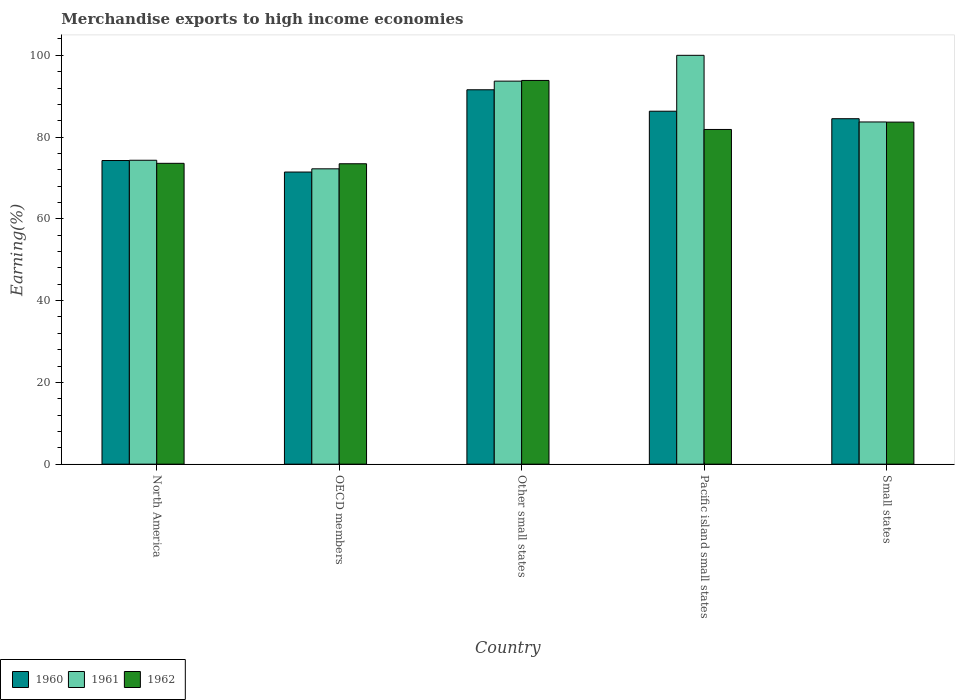How many different coloured bars are there?
Offer a very short reply. 3. Are the number of bars per tick equal to the number of legend labels?
Keep it short and to the point. Yes. How many bars are there on the 2nd tick from the left?
Offer a very short reply. 3. What is the label of the 3rd group of bars from the left?
Your answer should be compact. Other small states. What is the percentage of amount earned from merchandise exports in 1961 in North America?
Your answer should be very brief. 74.33. Across all countries, what is the minimum percentage of amount earned from merchandise exports in 1962?
Give a very brief answer. 73.48. In which country was the percentage of amount earned from merchandise exports in 1960 maximum?
Provide a short and direct response. Other small states. In which country was the percentage of amount earned from merchandise exports in 1960 minimum?
Offer a terse response. OECD members. What is the total percentage of amount earned from merchandise exports in 1962 in the graph?
Make the answer very short. 406.45. What is the difference between the percentage of amount earned from merchandise exports in 1962 in OECD members and that in Small states?
Your response must be concise. -10.19. What is the difference between the percentage of amount earned from merchandise exports in 1961 in OECD members and the percentage of amount earned from merchandise exports in 1960 in Small states?
Offer a terse response. -12.25. What is the average percentage of amount earned from merchandise exports in 1961 per country?
Give a very brief answer. 84.79. What is the difference between the percentage of amount earned from merchandise exports of/in 1961 and percentage of amount earned from merchandise exports of/in 1960 in Pacific island small states?
Your response must be concise. 13.67. In how many countries, is the percentage of amount earned from merchandise exports in 1962 greater than 92 %?
Provide a short and direct response. 1. What is the ratio of the percentage of amount earned from merchandise exports in 1962 in North America to that in Pacific island small states?
Provide a short and direct response. 0.9. Is the percentage of amount earned from merchandise exports in 1961 in North America less than that in Small states?
Offer a terse response. Yes. Is the difference between the percentage of amount earned from merchandise exports in 1961 in Other small states and Small states greater than the difference between the percentage of amount earned from merchandise exports in 1960 in Other small states and Small states?
Offer a very short reply. Yes. What is the difference between the highest and the second highest percentage of amount earned from merchandise exports in 1961?
Give a very brief answer. -16.3. What is the difference between the highest and the lowest percentage of amount earned from merchandise exports in 1960?
Give a very brief answer. 20.12. In how many countries, is the percentage of amount earned from merchandise exports in 1960 greater than the average percentage of amount earned from merchandise exports in 1960 taken over all countries?
Offer a very short reply. 3. What does the 2nd bar from the right in Pacific island small states represents?
Your answer should be very brief. 1961. Is it the case that in every country, the sum of the percentage of amount earned from merchandise exports in 1962 and percentage of amount earned from merchandise exports in 1961 is greater than the percentage of amount earned from merchandise exports in 1960?
Give a very brief answer. Yes. Are all the bars in the graph horizontal?
Keep it short and to the point. No. How many countries are there in the graph?
Ensure brevity in your answer.  5. Does the graph contain any zero values?
Keep it short and to the point. No. Does the graph contain grids?
Offer a very short reply. No. How are the legend labels stacked?
Offer a terse response. Horizontal. What is the title of the graph?
Make the answer very short. Merchandise exports to high income economies. What is the label or title of the X-axis?
Keep it short and to the point. Country. What is the label or title of the Y-axis?
Make the answer very short. Earning(%). What is the Earning(%) in 1960 in North America?
Provide a short and direct response. 74.27. What is the Earning(%) in 1961 in North America?
Provide a short and direct response. 74.33. What is the Earning(%) in 1962 in North America?
Ensure brevity in your answer.  73.58. What is the Earning(%) in 1960 in OECD members?
Your answer should be very brief. 71.45. What is the Earning(%) in 1961 in OECD members?
Keep it short and to the point. 72.24. What is the Earning(%) in 1962 in OECD members?
Make the answer very short. 73.48. What is the Earning(%) in 1960 in Other small states?
Your response must be concise. 91.57. What is the Earning(%) in 1961 in Other small states?
Offer a very short reply. 93.69. What is the Earning(%) in 1962 in Other small states?
Keep it short and to the point. 93.86. What is the Earning(%) of 1960 in Pacific island small states?
Provide a short and direct response. 86.33. What is the Earning(%) in 1962 in Pacific island small states?
Your answer should be very brief. 81.86. What is the Earning(%) in 1960 in Small states?
Keep it short and to the point. 84.49. What is the Earning(%) of 1961 in Small states?
Keep it short and to the point. 83.7. What is the Earning(%) of 1962 in Small states?
Provide a short and direct response. 83.67. Across all countries, what is the maximum Earning(%) in 1960?
Ensure brevity in your answer.  91.57. Across all countries, what is the maximum Earning(%) of 1961?
Your response must be concise. 100. Across all countries, what is the maximum Earning(%) in 1962?
Your answer should be compact. 93.86. Across all countries, what is the minimum Earning(%) of 1960?
Offer a very short reply. 71.45. Across all countries, what is the minimum Earning(%) of 1961?
Your answer should be compact. 72.24. Across all countries, what is the minimum Earning(%) of 1962?
Provide a short and direct response. 73.48. What is the total Earning(%) in 1960 in the graph?
Your answer should be compact. 408.11. What is the total Earning(%) of 1961 in the graph?
Offer a very short reply. 423.95. What is the total Earning(%) of 1962 in the graph?
Your answer should be compact. 406.45. What is the difference between the Earning(%) in 1960 in North America and that in OECD members?
Your answer should be very brief. 2.82. What is the difference between the Earning(%) in 1961 in North America and that in OECD members?
Keep it short and to the point. 2.09. What is the difference between the Earning(%) of 1962 in North America and that in OECD members?
Provide a short and direct response. 0.11. What is the difference between the Earning(%) of 1960 in North America and that in Other small states?
Keep it short and to the point. -17.3. What is the difference between the Earning(%) of 1961 in North America and that in Other small states?
Your response must be concise. -19.35. What is the difference between the Earning(%) in 1962 in North America and that in Other small states?
Provide a succinct answer. -20.27. What is the difference between the Earning(%) of 1960 in North America and that in Pacific island small states?
Give a very brief answer. -12.06. What is the difference between the Earning(%) in 1961 in North America and that in Pacific island small states?
Your answer should be compact. -25.67. What is the difference between the Earning(%) of 1962 in North America and that in Pacific island small states?
Provide a succinct answer. -8.28. What is the difference between the Earning(%) in 1960 in North America and that in Small states?
Provide a succinct answer. -10.23. What is the difference between the Earning(%) in 1961 in North America and that in Small states?
Keep it short and to the point. -9.37. What is the difference between the Earning(%) in 1962 in North America and that in Small states?
Provide a short and direct response. -10.08. What is the difference between the Earning(%) in 1960 in OECD members and that in Other small states?
Your answer should be very brief. -20.12. What is the difference between the Earning(%) of 1961 in OECD members and that in Other small states?
Provide a short and direct response. -21.45. What is the difference between the Earning(%) of 1962 in OECD members and that in Other small states?
Your response must be concise. -20.38. What is the difference between the Earning(%) of 1960 in OECD members and that in Pacific island small states?
Give a very brief answer. -14.88. What is the difference between the Earning(%) of 1961 in OECD members and that in Pacific island small states?
Provide a succinct answer. -27.76. What is the difference between the Earning(%) in 1962 in OECD members and that in Pacific island small states?
Make the answer very short. -8.39. What is the difference between the Earning(%) of 1960 in OECD members and that in Small states?
Offer a terse response. -13.04. What is the difference between the Earning(%) of 1961 in OECD members and that in Small states?
Make the answer very short. -11.46. What is the difference between the Earning(%) of 1962 in OECD members and that in Small states?
Your response must be concise. -10.19. What is the difference between the Earning(%) in 1960 in Other small states and that in Pacific island small states?
Your answer should be compact. 5.24. What is the difference between the Earning(%) in 1961 in Other small states and that in Pacific island small states?
Offer a terse response. -6.31. What is the difference between the Earning(%) of 1962 in Other small states and that in Pacific island small states?
Ensure brevity in your answer.  11.99. What is the difference between the Earning(%) of 1960 in Other small states and that in Small states?
Ensure brevity in your answer.  7.08. What is the difference between the Earning(%) of 1961 in Other small states and that in Small states?
Your answer should be very brief. 9.99. What is the difference between the Earning(%) of 1962 in Other small states and that in Small states?
Provide a short and direct response. 10.19. What is the difference between the Earning(%) in 1960 in Pacific island small states and that in Small states?
Offer a very short reply. 1.84. What is the difference between the Earning(%) of 1961 in Pacific island small states and that in Small states?
Your answer should be compact. 16.3. What is the difference between the Earning(%) of 1962 in Pacific island small states and that in Small states?
Ensure brevity in your answer.  -1.8. What is the difference between the Earning(%) in 1960 in North America and the Earning(%) in 1961 in OECD members?
Your response must be concise. 2.03. What is the difference between the Earning(%) in 1960 in North America and the Earning(%) in 1962 in OECD members?
Give a very brief answer. 0.79. What is the difference between the Earning(%) in 1961 in North America and the Earning(%) in 1962 in OECD members?
Offer a very short reply. 0.85. What is the difference between the Earning(%) of 1960 in North America and the Earning(%) of 1961 in Other small states?
Offer a terse response. -19.42. What is the difference between the Earning(%) in 1960 in North America and the Earning(%) in 1962 in Other small states?
Offer a very short reply. -19.59. What is the difference between the Earning(%) of 1961 in North America and the Earning(%) of 1962 in Other small states?
Your answer should be very brief. -19.52. What is the difference between the Earning(%) in 1960 in North America and the Earning(%) in 1961 in Pacific island small states?
Offer a very short reply. -25.73. What is the difference between the Earning(%) of 1960 in North America and the Earning(%) of 1962 in Pacific island small states?
Ensure brevity in your answer.  -7.6. What is the difference between the Earning(%) in 1961 in North America and the Earning(%) in 1962 in Pacific island small states?
Provide a short and direct response. -7.53. What is the difference between the Earning(%) of 1960 in North America and the Earning(%) of 1961 in Small states?
Keep it short and to the point. -9.43. What is the difference between the Earning(%) in 1960 in North America and the Earning(%) in 1962 in Small states?
Ensure brevity in your answer.  -9.4. What is the difference between the Earning(%) in 1961 in North America and the Earning(%) in 1962 in Small states?
Provide a short and direct response. -9.34. What is the difference between the Earning(%) of 1960 in OECD members and the Earning(%) of 1961 in Other small states?
Ensure brevity in your answer.  -22.23. What is the difference between the Earning(%) of 1960 in OECD members and the Earning(%) of 1962 in Other small states?
Provide a succinct answer. -22.4. What is the difference between the Earning(%) of 1961 in OECD members and the Earning(%) of 1962 in Other small states?
Provide a succinct answer. -21.62. What is the difference between the Earning(%) of 1960 in OECD members and the Earning(%) of 1961 in Pacific island small states?
Make the answer very short. -28.55. What is the difference between the Earning(%) in 1960 in OECD members and the Earning(%) in 1962 in Pacific island small states?
Offer a very short reply. -10.41. What is the difference between the Earning(%) in 1961 in OECD members and the Earning(%) in 1962 in Pacific island small states?
Make the answer very short. -9.63. What is the difference between the Earning(%) of 1960 in OECD members and the Earning(%) of 1961 in Small states?
Your answer should be very brief. -12.25. What is the difference between the Earning(%) in 1960 in OECD members and the Earning(%) in 1962 in Small states?
Provide a succinct answer. -12.22. What is the difference between the Earning(%) of 1961 in OECD members and the Earning(%) of 1962 in Small states?
Give a very brief answer. -11.43. What is the difference between the Earning(%) in 1960 in Other small states and the Earning(%) in 1961 in Pacific island small states?
Offer a terse response. -8.43. What is the difference between the Earning(%) of 1960 in Other small states and the Earning(%) of 1962 in Pacific island small states?
Offer a very short reply. 9.71. What is the difference between the Earning(%) in 1961 in Other small states and the Earning(%) in 1962 in Pacific island small states?
Your answer should be very brief. 11.82. What is the difference between the Earning(%) of 1960 in Other small states and the Earning(%) of 1961 in Small states?
Keep it short and to the point. 7.87. What is the difference between the Earning(%) of 1960 in Other small states and the Earning(%) of 1962 in Small states?
Offer a terse response. 7.9. What is the difference between the Earning(%) in 1961 in Other small states and the Earning(%) in 1962 in Small states?
Provide a succinct answer. 10.02. What is the difference between the Earning(%) of 1960 in Pacific island small states and the Earning(%) of 1961 in Small states?
Your answer should be compact. 2.63. What is the difference between the Earning(%) of 1960 in Pacific island small states and the Earning(%) of 1962 in Small states?
Offer a terse response. 2.66. What is the difference between the Earning(%) in 1961 in Pacific island small states and the Earning(%) in 1962 in Small states?
Offer a very short reply. 16.33. What is the average Earning(%) of 1960 per country?
Give a very brief answer. 81.62. What is the average Earning(%) in 1961 per country?
Keep it short and to the point. 84.79. What is the average Earning(%) of 1962 per country?
Provide a succinct answer. 81.29. What is the difference between the Earning(%) in 1960 and Earning(%) in 1961 in North America?
Provide a short and direct response. -0.07. What is the difference between the Earning(%) in 1960 and Earning(%) in 1962 in North America?
Give a very brief answer. 0.68. What is the difference between the Earning(%) of 1961 and Earning(%) of 1962 in North America?
Your response must be concise. 0.75. What is the difference between the Earning(%) in 1960 and Earning(%) in 1961 in OECD members?
Offer a very short reply. -0.79. What is the difference between the Earning(%) of 1960 and Earning(%) of 1962 in OECD members?
Provide a short and direct response. -2.03. What is the difference between the Earning(%) in 1961 and Earning(%) in 1962 in OECD members?
Give a very brief answer. -1.24. What is the difference between the Earning(%) in 1960 and Earning(%) in 1961 in Other small states?
Your answer should be compact. -2.11. What is the difference between the Earning(%) of 1960 and Earning(%) of 1962 in Other small states?
Your answer should be very brief. -2.28. What is the difference between the Earning(%) of 1961 and Earning(%) of 1962 in Other small states?
Make the answer very short. -0.17. What is the difference between the Earning(%) in 1960 and Earning(%) in 1961 in Pacific island small states?
Your response must be concise. -13.67. What is the difference between the Earning(%) of 1960 and Earning(%) of 1962 in Pacific island small states?
Your answer should be compact. 4.47. What is the difference between the Earning(%) of 1961 and Earning(%) of 1962 in Pacific island small states?
Your answer should be compact. 18.14. What is the difference between the Earning(%) in 1960 and Earning(%) in 1961 in Small states?
Give a very brief answer. 0.79. What is the difference between the Earning(%) in 1960 and Earning(%) in 1962 in Small states?
Ensure brevity in your answer.  0.83. What is the difference between the Earning(%) of 1961 and Earning(%) of 1962 in Small states?
Make the answer very short. 0.03. What is the ratio of the Earning(%) in 1960 in North America to that in OECD members?
Offer a very short reply. 1.04. What is the ratio of the Earning(%) in 1960 in North America to that in Other small states?
Your answer should be very brief. 0.81. What is the ratio of the Earning(%) of 1961 in North America to that in Other small states?
Your response must be concise. 0.79. What is the ratio of the Earning(%) in 1962 in North America to that in Other small states?
Provide a short and direct response. 0.78. What is the ratio of the Earning(%) of 1960 in North America to that in Pacific island small states?
Ensure brevity in your answer.  0.86. What is the ratio of the Earning(%) of 1961 in North America to that in Pacific island small states?
Offer a terse response. 0.74. What is the ratio of the Earning(%) of 1962 in North America to that in Pacific island small states?
Provide a succinct answer. 0.9. What is the ratio of the Earning(%) in 1960 in North America to that in Small states?
Your answer should be compact. 0.88. What is the ratio of the Earning(%) of 1961 in North America to that in Small states?
Make the answer very short. 0.89. What is the ratio of the Earning(%) of 1962 in North America to that in Small states?
Your answer should be very brief. 0.88. What is the ratio of the Earning(%) in 1960 in OECD members to that in Other small states?
Ensure brevity in your answer.  0.78. What is the ratio of the Earning(%) of 1961 in OECD members to that in Other small states?
Your response must be concise. 0.77. What is the ratio of the Earning(%) in 1962 in OECD members to that in Other small states?
Give a very brief answer. 0.78. What is the ratio of the Earning(%) of 1960 in OECD members to that in Pacific island small states?
Provide a short and direct response. 0.83. What is the ratio of the Earning(%) of 1961 in OECD members to that in Pacific island small states?
Ensure brevity in your answer.  0.72. What is the ratio of the Earning(%) in 1962 in OECD members to that in Pacific island small states?
Offer a terse response. 0.9. What is the ratio of the Earning(%) of 1960 in OECD members to that in Small states?
Your answer should be very brief. 0.85. What is the ratio of the Earning(%) of 1961 in OECD members to that in Small states?
Provide a succinct answer. 0.86. What is the ratio of the Earning(%) of 1962 in OECD members to that in Small states?
Provide a short and direct response. 0.88. What is the ratio of the Earning(%) in 1960 in Other small states to that in Pacific island small states?
Provide a short and direct response. 1.06. What is the ratio of the Earning(%) of 1961 in Other small states to that in Pacific island small states?
Offer a terse response. 0.94. What is the ratio of the Earning(%) in 1962 in Other small states to that in Pacific island small states?
Your answer should be compact. 1.15. What is the ratio of the Earning(%) in 1960 in Other small states to that in Small states?
Your response must be concise. 1.08. What is the ratio of the Earning(%) of 1961 in Other small states to that in Small states?
Give a very brief answer. 1.12. What is the ratio of the Earning(%) in 1962 in Other small states to that in Small states?
Ensure brevity in your answer.  1.12. What is the ratio of the Earning(%) of 1960 in Pacific island small states to that in Small states?
Keep it short and to the point. 1.02. What is the ratio of the Earning(%) in 1961 in Pacific island small states to that in Small states?
Your answer should be compact. 1.19. What is the ratio of the Earning(%) of 1962 in Pacific island small states to that in Small states?
Your response must be concise. 0.98. What is the difference between the highest and the second highest Earning(%) in 1960?
Ensure brevity in your answer.  5.24. What is the difference between the highest and the second highest Earning(%) of 1961?
Your answer should be compact. 6.31. What is the difference between the highest and the second highest Earning(%) in 1962?
Provide a succinct answer. 10.19. What is the difference between the highest and the lowest Earning(%) in 1960?
Offer a very short reply. 20.12. What is the difference between the highest and the lowest Earning(%) of 1961?
Provide a succinct answer. 27.76. What is the difference between the highest and the lowest Earning(%) of 1962?
Make the answer very short. 20.38. 